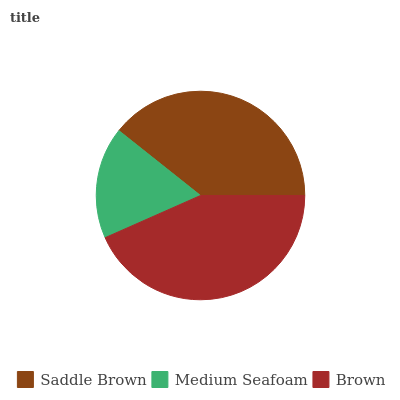Is Medium Seafoam the minimum?
Answer yes or no. Yes. Is Brown the maximum?
Answer yes or no. Yes. Is Brown the minimum?
Answer yes or no. No. Is Medium Seafoam the maximum?
Answer yes or no. No. Is Brown greater than Medium Seafoam?
Answer yes or no. Yes. Is Medium Seafoam less than Brown?
Answer yes or no. Yes. Is Medium Seafoam greater than Brown?
Answer yes or no. No. Is Brown less than Medium Seafoam?
Answer yes or no. No. Is Saddle Brown the high median?
Answer yes or no. Yes. Is Saddle Brown the low median?
Answer yes or no. Yes. Is Medium Seafoam the high median?
Answer yes or no. No. Is Brown the low median?
Answer yes or no. No. 